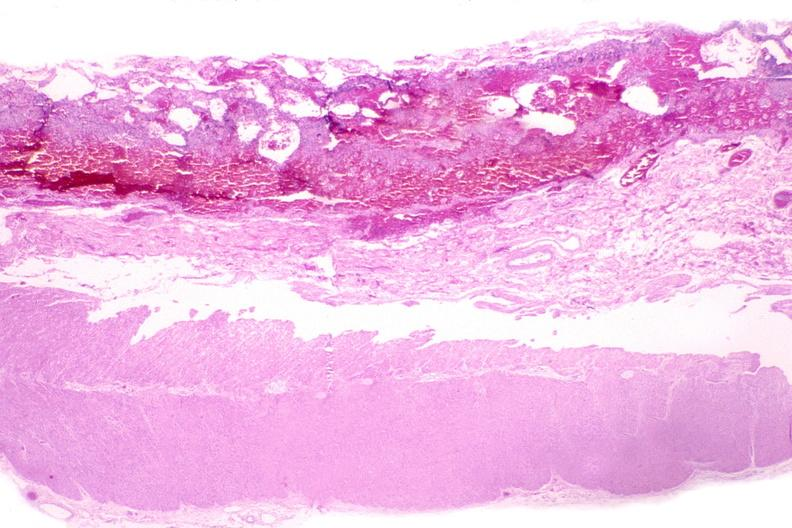does endocervical polyp show esohagus, candida?
Answer the question using a single word or phrase. No 